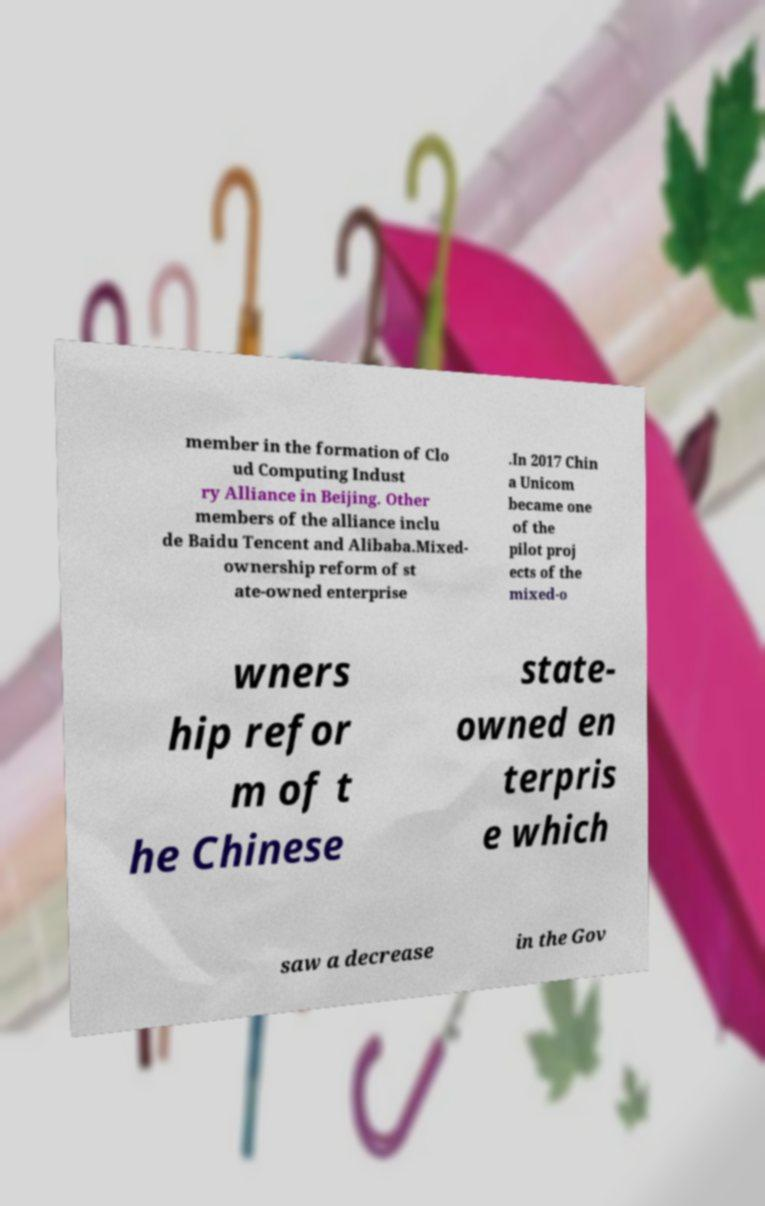I need the written content from this picture converted into text. Can you do that? member in the formation of Clo ud Computing Indust ry Alliance in Beijing. Other members of the alliance inclu de Baidu Tencent and Alibaba.Mixed- ownership reform of st ate-owned enterprise .In 2017 Chin a Unicom became one of the pilot proj ects of the mixed-o wners hip refor m of t he Chinese state- owned en terpris e which saw a decrease in the Gov 